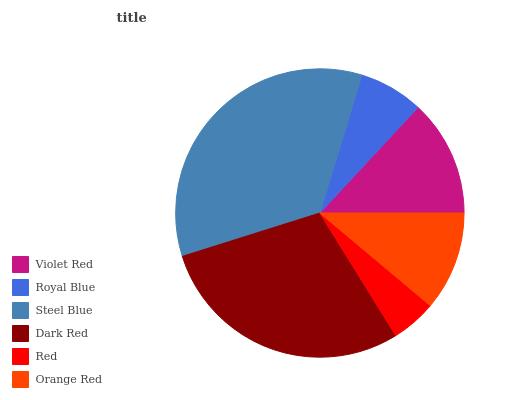Is Red the minimum?
Answer yes or no. Yes. Is Steel Blue the maximum?
Answer yes or no. Yes. Is Royal Blue the minimum?
Answer yes or no. No. Is Royal Blue the maximum?
Answer yes or no. No. Is Violet Red greater than Royal Blue?
Answer yes or no. Yes. Is Royal Blue less than Violet Red?
Answer yes or no. Yes. Is Royal Blue greater than Violet Red?
Answer yes or no. No. Is Violet Red less than Royal Blue?
Answer yes or no. No. Is Violet Red the high median?
Answer yes or no. Yes. Is Orange Red the low median?
Answer yes or no. Yes. Is Royal Blue the high median?
Answer yes or no. No. Is Red the low median?
Answer yes or no. No. 